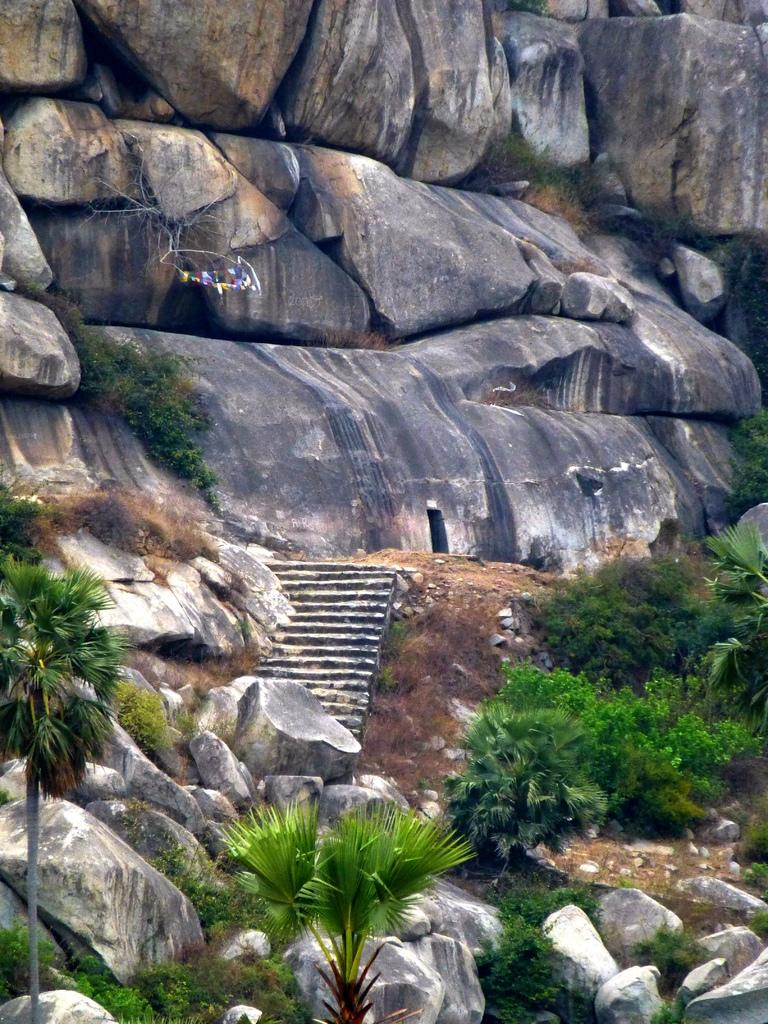What type of terrain is visible at the bottom of the picture? There is grass, trees, and rocks at the bottom of the picture. What architectural feature can be seen in the middle of the picture? There is a staircase in the middle of the picture. What type of objects can be seen in the background of the picture? There are rocks and trees in the background of the picture. How many houses are visible in the wilderness in the image? There are no houses visible in the image, and the term "wilderness" is not applicable to the scene depicted. 